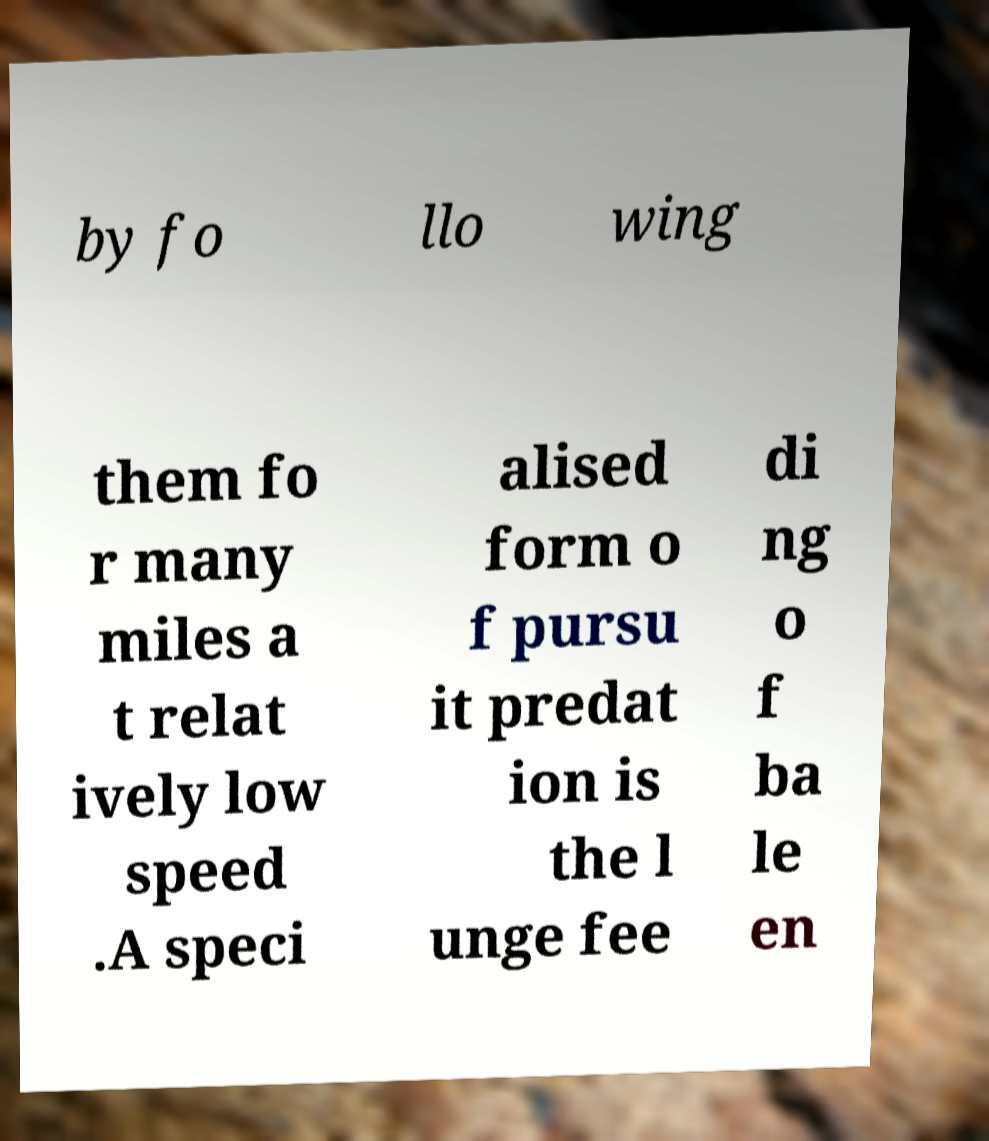Please read and relay the text visible in this image. What does it say? by fo llo wing them fo r many miles a t relat ively low speed .A speci alised form o f pursu it predat ion is the l unge fee di ng o f ba le en 